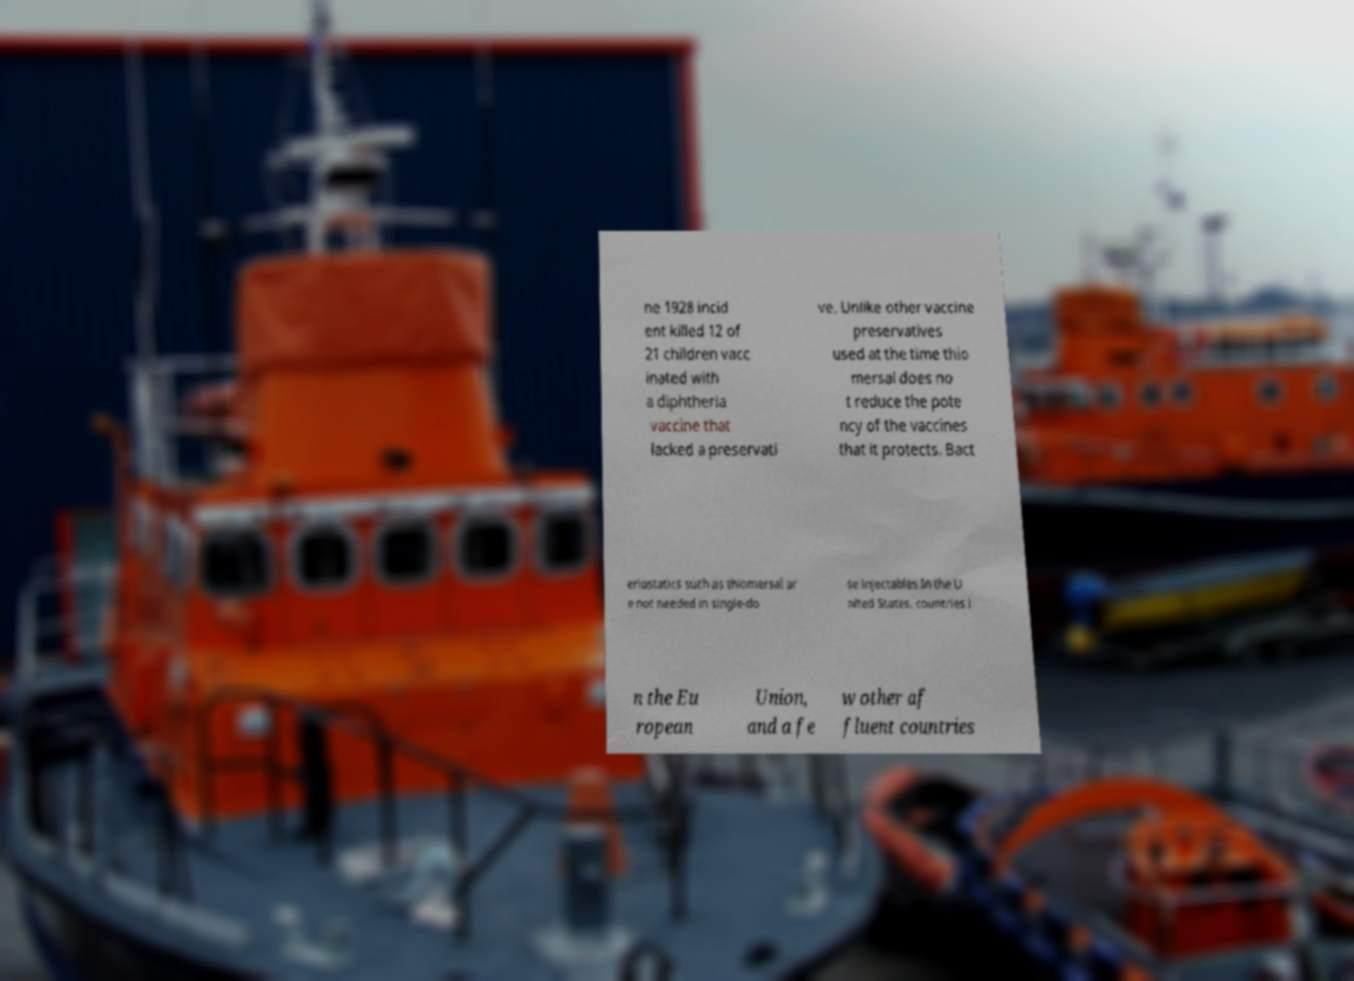Can you accurately transcribe the text from the provided image for me? ne 1928 incid ent killed 12 of 21 children vacc inated with a diphtheria vaccine that lacked a preservati ve. Unlike other vaccine preservatives used at the time thio mersal does no t reduce the pote ncy of the vaccines that it protects. Bact eriostatics such as thiomersal ar e not needed in single-do se injectables.In the U nited States, countries i n the Eu ropean Union, and a fe w other af fluent countries 